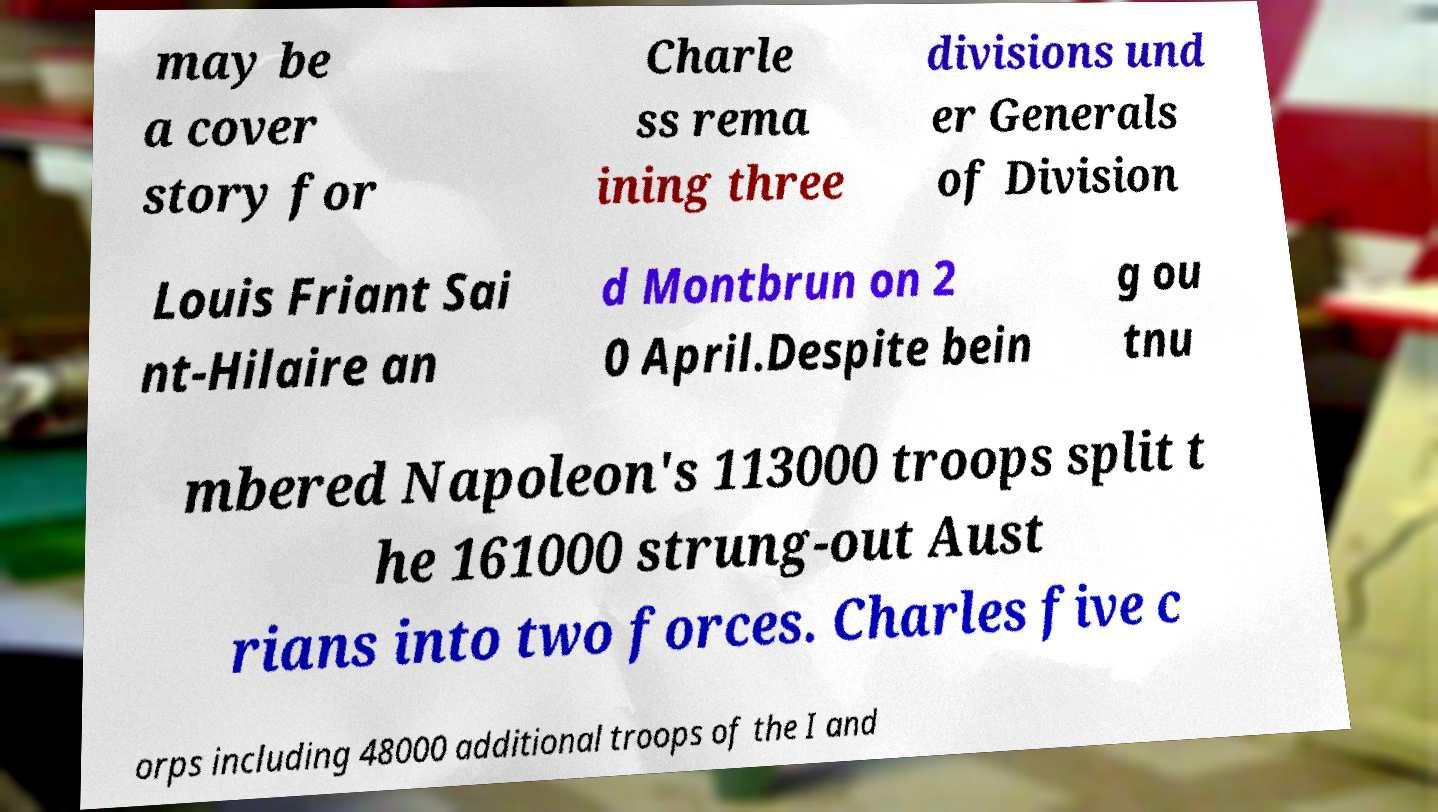Could you extract and type out the text from this image? may be a cover story for Charle ss rema ining three divisions und er Generals of Division Louis Friant Sai nt-Hilaire an d Montbrun on 2 0 April.Despite bein g ou tnu mbered Napoleon's 113000 troops split t he 161000 strung-out Aust rians into two forces. Charles five c orps including 48000 additional troops of the I and 